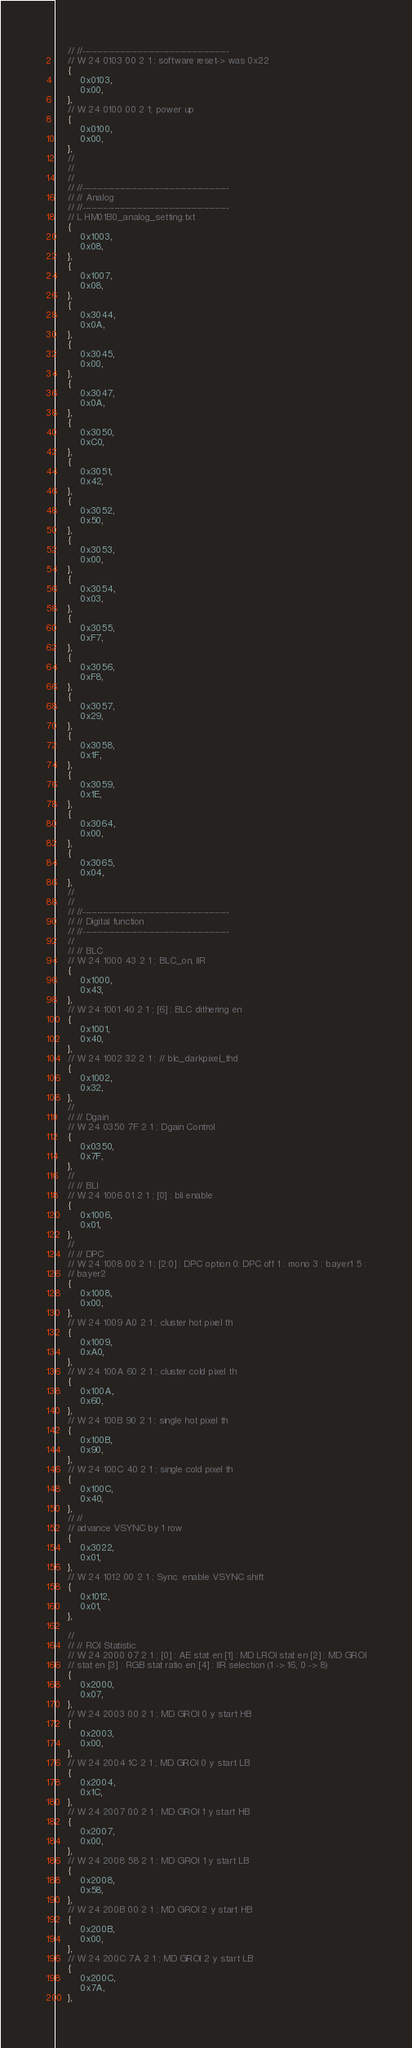<code> <loc_0><loc_0><loc_500><loc_500><_C_>    // //---------------------------------------------------
    // W 24 0103 00 2 1 ; software reset-> was 0x22
    {
        0x0103,
        0x00,
    },
    // W 24 0100 00 2 1; power up
    {
        0x0100,
        0x00,
    },
    //
    //
    //
    // //---------------------------------------------------
    // // Analog
    // //---------------------------------------------------
    // L HM01B0_analog_setting.txt
    {
        0x1003,
        0x08,
    },
    {
        0x1007,
        0x08,
    },
    {
        0x3044,
        0x0A,
    },
    {
        0x3045,
        0x00,
    },
    {
        0x3047,
        0x0A,
    },
    {
        0x3050,
        0xC0,
    },
    {
        0x3051,
        0x42,
    },
    {
        0x3052,
        0x50,
    },
    {
        0x3053,
        0x00,
    },
    {
        0x3054,
        0x03,
    },
    {
        0x3055,
        0xF7,
    },
    {
        0x3056,
        0xF8,
    },
    {
        0x3057,
        0x29,
    },
    {
        0x3058,
        0x1F,
    },
    {
        0x3059,
        0x1E,
    },
    {
        0x3064,
        0x00,
    },
    {
        0x3065,
        0x04,
    },
    //
    //
    // //---------------------------------------------------
    // // Digital function
    // //---------------------------------------------------
    //
    // // BLC
    // W 24 1000 43 2 1 ; BLC_on, IIR
    {
        0x1000,
        0x43,
    },
    // W 24 1001 40 2 1 ; [6] : BLC dithering en
    {
        0x1001,
        0x40,
    },
    // W 24 1002 32 2 1 ; // blc_darkpixel_thd
    {
        0x1002,
        0x32,
    },
    //
    // // Dgain
    // W 24 0350 7F 2 1 ; Dgain Control
    {
        0x0350,
        0x7F,
    },
    //
    // // BLI
    // W 24 1006 01 2 1 ; [0] : bli enable
    {
        0x1006,
        0x01,
    },
    //
    // // DPC
    // W 24 1008 00 2 1 ; [2:0] : DPC option 0: DPC off 1 : mono 3 : bayer1 5 :
    // bayer2
    {
        0x1008,
        0x00,
    },
    // W 24 1009 A0 2 1 ; cluster hot pixel th
    {
        0x1009,
        0xA0,
    },
    // W 24 100A 60 2 1 ; cluster cold pixel th
    {
        0x100A,
        0x60,
    },
    // W 24 100B 90 2 1 ; single hot pixel th
    {
        0x100B,
        0x90,
    },
    // W 24 100C 40 2 1 ; single cold pixel th
    {
        0x100C,
        0x40,
    },
    // //
    // advance VSYNC by 1 row
    {
        0x3022,
        0x01,
    },
    // W 24 1012 00 2 1 ; Sync. enable VSYNC shift
    {
        0x1012,
        0x01,
    },

    //
    // // ROI Statistic
    // W 24 2000 07 2 1 ; [0] : AE stat en [1] : MD LROI stat en [2] : MD GROI
    // stat en [3] : RGB stat ratio en [4] : IIR selection (1 -> 16, 0 -> 8)
    {
        0x2000,
        0x07,
    },
    // W 24 2003 00 2 1 ; MD GROI 0 y start HB
    {
        0x2003,
        0x00,
    },
    // W 24 2004 1C 2 1 ; MD GROI 0 y start LB
    {
        0x2004,
        0x1C,
    },
    // W 24 2007 00 2 1 ; MD GROI 1 y start HB
    {
        0x2007,
        0x00,
    },
    // W 24 2008 58 2 1 ; MD GROI 1 y start LB
    {
        0x2008,
        0x58,
    },
    // W 24 200B 00 2 1 ; MD GROI 2 y start HB
    {
        0x200B,
        0x00,
    },
    // W 24 200C 7A 2 1 ; MD GROI 2 y start LB
    {
        0x200C,
        0x7A,
    },</code> 